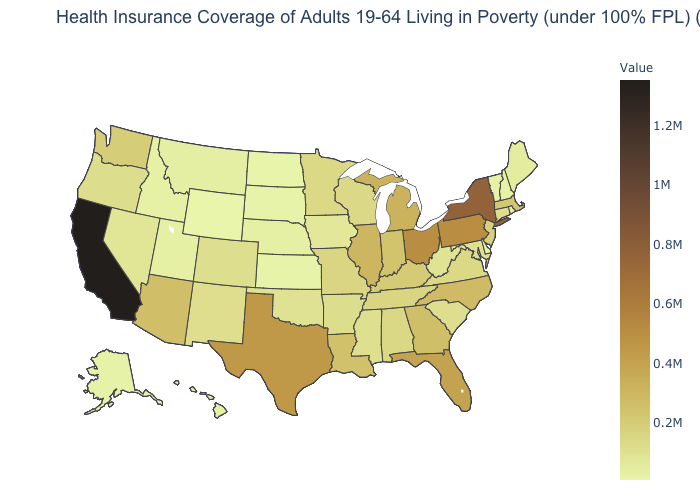Which states have the lowest value in the USA?
Keep it brief. Wyoming. Which states have the highest value in the USA?
Be succinct. California. Is the legend a continuous bar?
Short answer required. Yes. Among the states that border Massachusetts , does New York have the highest value?
Give a very brief answer. Yes. Does New York have the lowest value in the USA?
Be succinct. No. Among the states that border California , which have the highest value?
Keep it brief. Arizona. Which states have the lowest value in the South?
Be succinct. Delaware. 